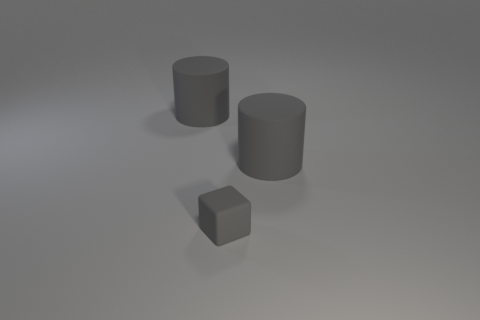How big is the gray rubber block?
Give a very brief answer. Small. What number of things are tiny things or big cylinders?
Offer a very short reply. 3. Is the shape of the big gray object left of the tiny gray rubber object the same as  the tiny gray rubber object?
Ensure brevity in your answer.  No. How many objects are either big matte things on the right side of the tiny gray cube or big cylinders that are on the left side of the tiny gray cube?
Keep it short and to the point. 2. Is there anything else that is the same shape as the small gray matte thing?
Provide a succinct answer. No. There is a small gray rubber thing; is it the same shape as the matte thing on the left side of the tiny block?
Keep it short and to the point. No. What is the gray cube made of?
Ensure brevity in your answer.  Rubber. What number of other objects are there of the same material as the small gray block?
Your response must be concise. 2. Are the tiny gray block and the big gray cylinder that is on the right side of the tiny rubber object made of the same material?
Provide a short and direct response. Yes. There is a thing left of the gray cube; what color is it?
Keep it short and to the point. Gray. 